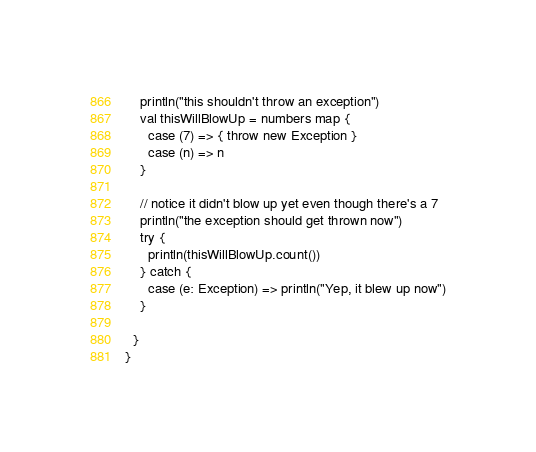Convert code to text. <code><loc_0><loc_0><loc_500><loc_500><_Scala_>    println("this shouldn't throw an exception")
    val thisWillBlowUp = numbers map {
      case (7) => { throw new Exception }
      case (n) => n
    }

    // notice it didn't blow up yet even though there's a 7
    println("the exception should get thrown now")
    try {
      println(thisWillBlowUp.count())
    } catch {
      case (e: Exception) => println("Yep, it blew up now")
    }

  }
}
</code> 